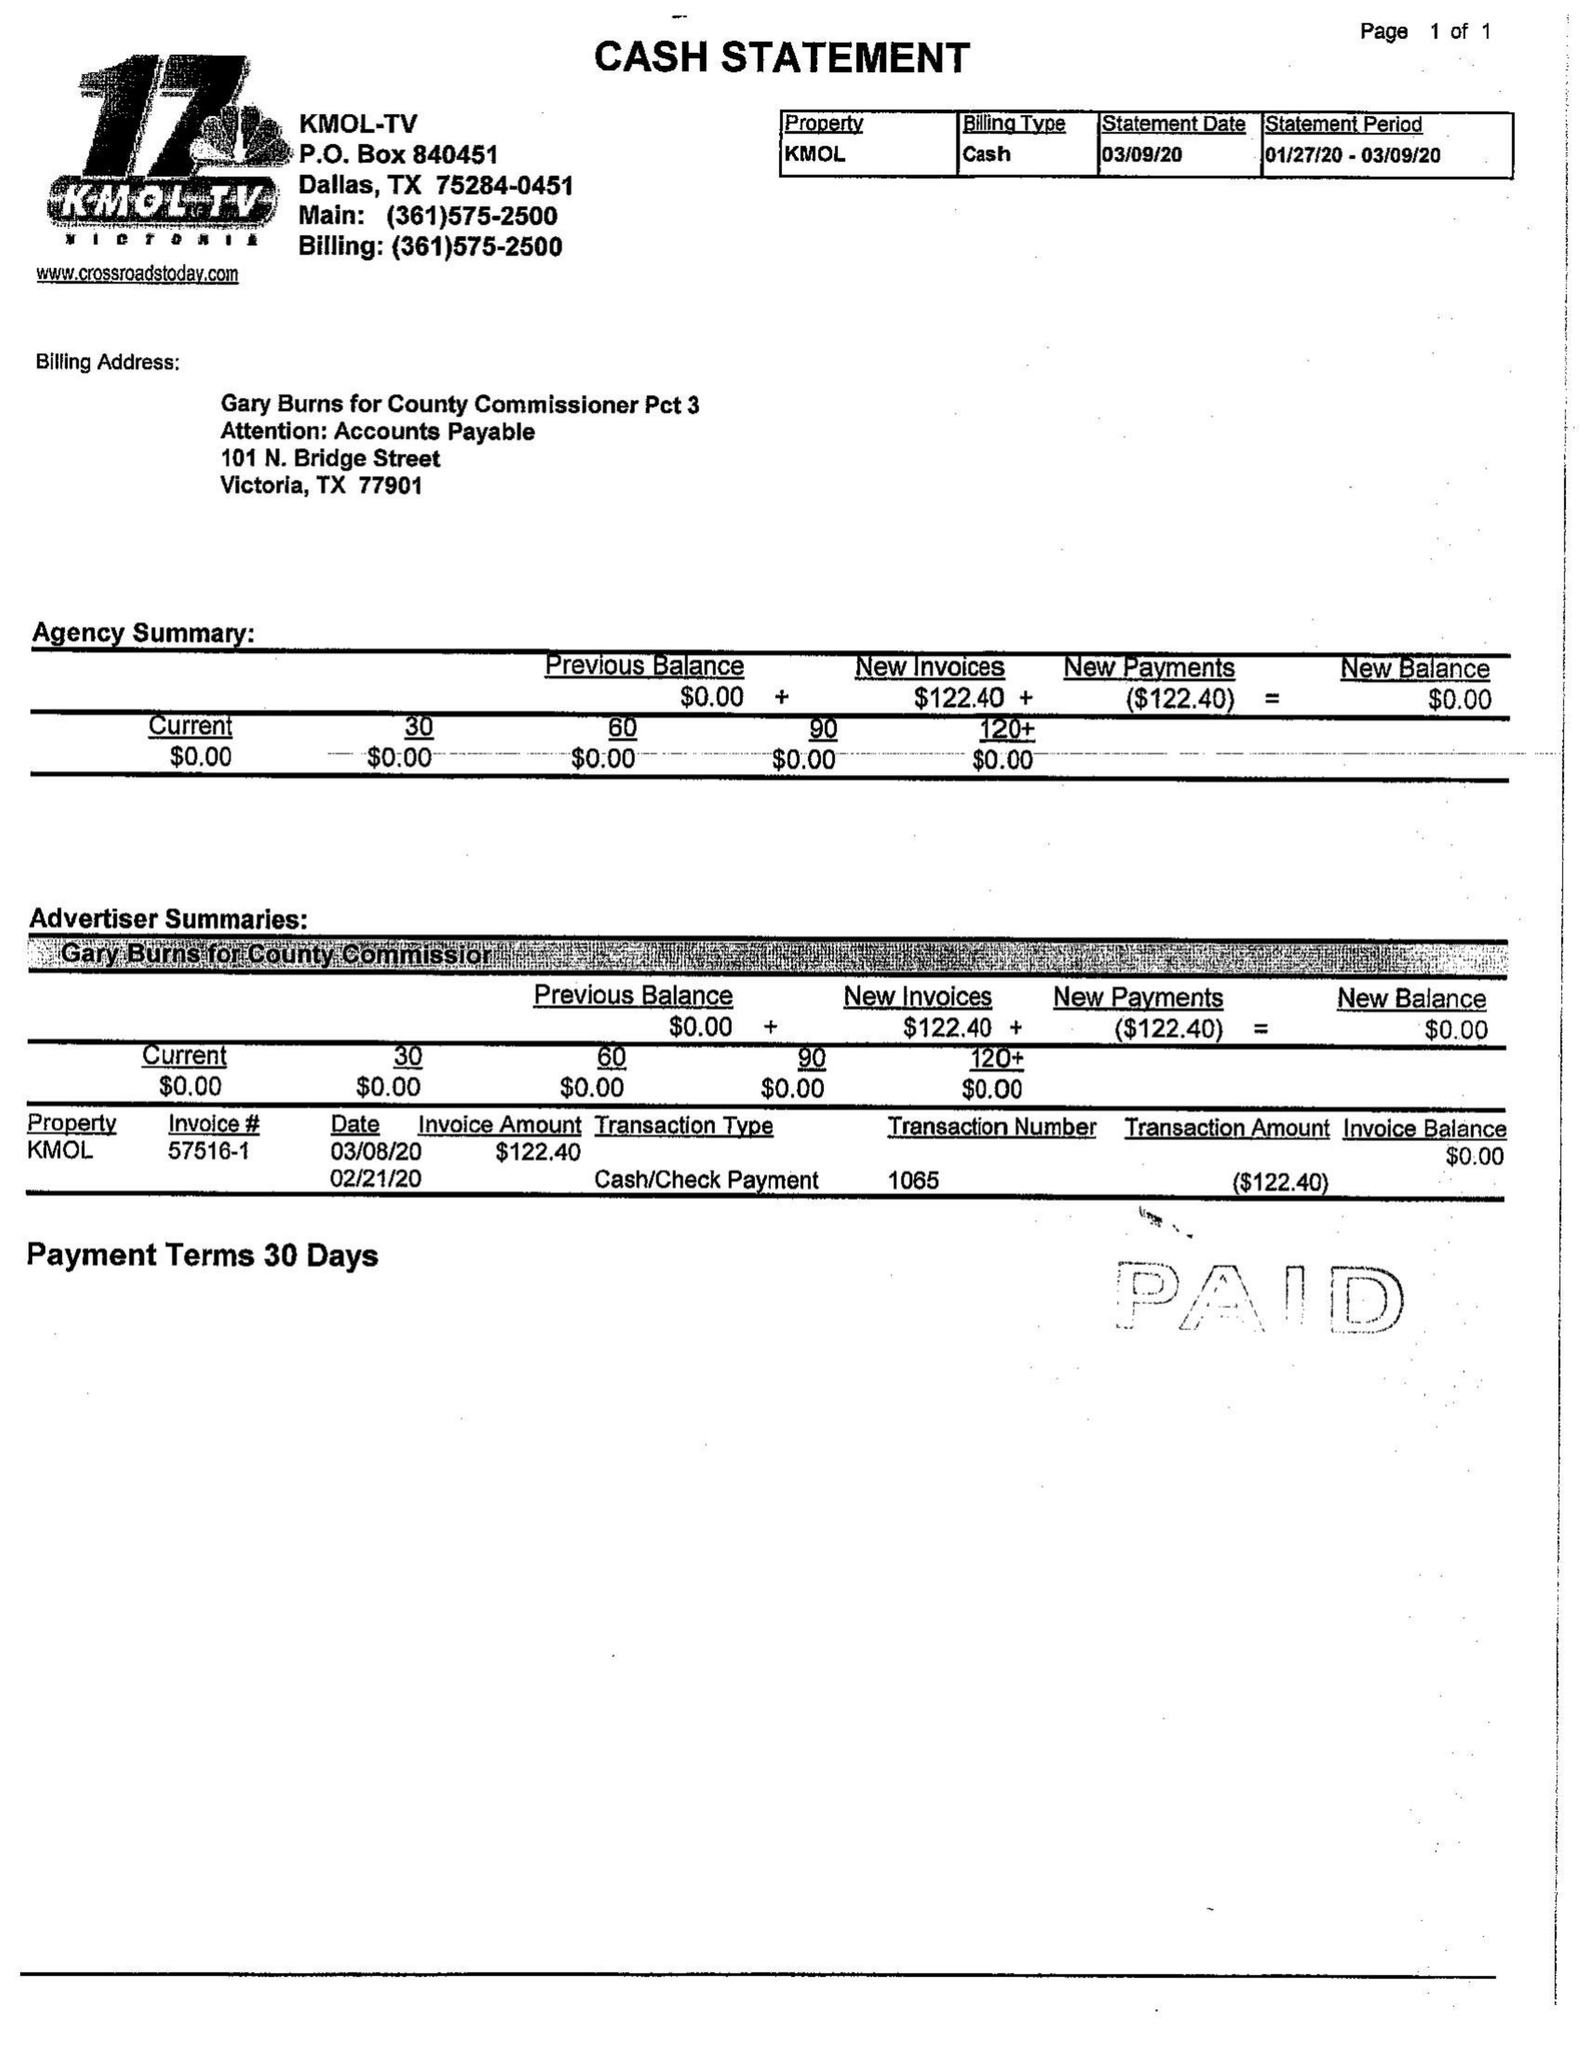What is the value for the flight_to?
Answer the question using a single word or phrase. 03/02/20 